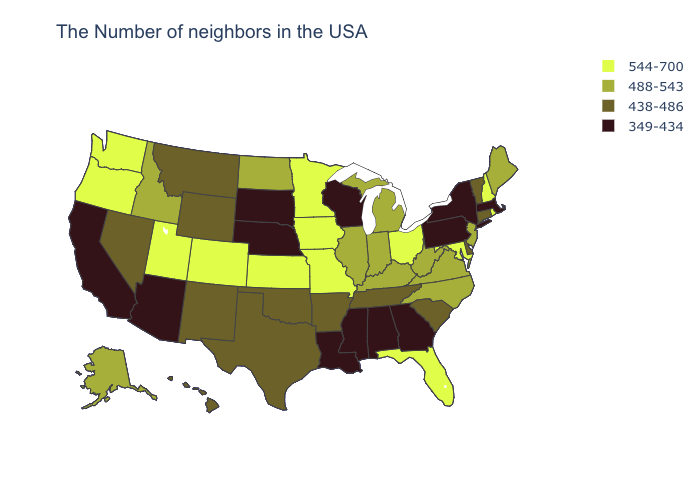Name the states that have a value in the range 438-486?
Concise answer only. Vermont, Connecticut, Delaware, South Carolina, Tennessee, Arkansas, Oklahoma, Texas, Wyoming, New Mexico, Montana, Nevada, Hawaii. Does the map have missing data?
Quick response, please. No. What is the highest value in states that border Illinois?
Keep it brief. 544-700. Among the states that border North Dakota , which have the lowest value?
Write a very short answer. South Dakota. Name the states that have a value in the range 488-543?
Concise answer only. Maine, New Jersey, Virginia, North Carolina, West Virginia, Michigan, Kentucky, Indiana, Illinois, North Dakota, Idaho, Alaska. Which states have the lowest value in the MidWest?
Concise answer only. Wisconsin, Nebraska, South Dakota. What is the value of Rhode Island?
Be succinct. 544-700. Name the states that have a value in the range 544-700?
Be succinct. Rhode Island, New Hampshire, Maryland, Ohio, Florida, Missouri, Minnesota, Iowa, Kansas, Colorado, Utah, Washington, Oregon. Name the states that have a value in the range 544-700?
Short answer required. Rhode Island, New Hampshire, Maryland, Ohio, Florida, Missouri, Minnesota, Iowa, Kansas, Colorado, Utah, Washington, Oregon. Does the first symbol in the legend represent the smallest category?
Write a very short answer. No. How many symbols are there in the legend?
Give a very brief answer. 4. Is the legend a continuous bar?
Keep it brief. No. Among the states that border Georgia , does Alabama have the highest value?
Concise answer only. No. What is the value of Florida?
Concise answer only. 544-700. 